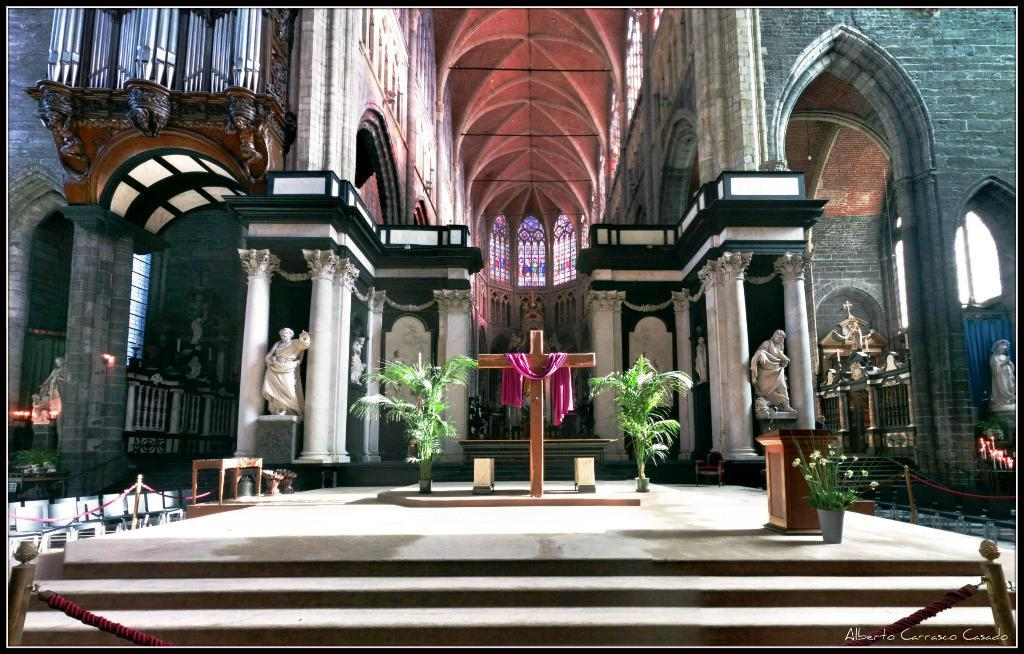What type of building is depicted in the image? The image is an inside view of a church. What type of decorative elements can be seen in the image? There are plants, a holy cross, and a sculpture in the image. What architectural features are present in the image? There are pillars, walls, railings, stairs, ropes, and poles in the image. What type of seating is available in the image? There are chairs in the image. How many fish can be seen swimming in the holy water font in the image? There are no fish present in the image, as it is an inside view of a church and not a scene involving water. What type of gold ornaments are displayed on the walls in the image? There is no mention of gold ornaments in the image; the focus is on the architectural features and decorative elements of the church. 